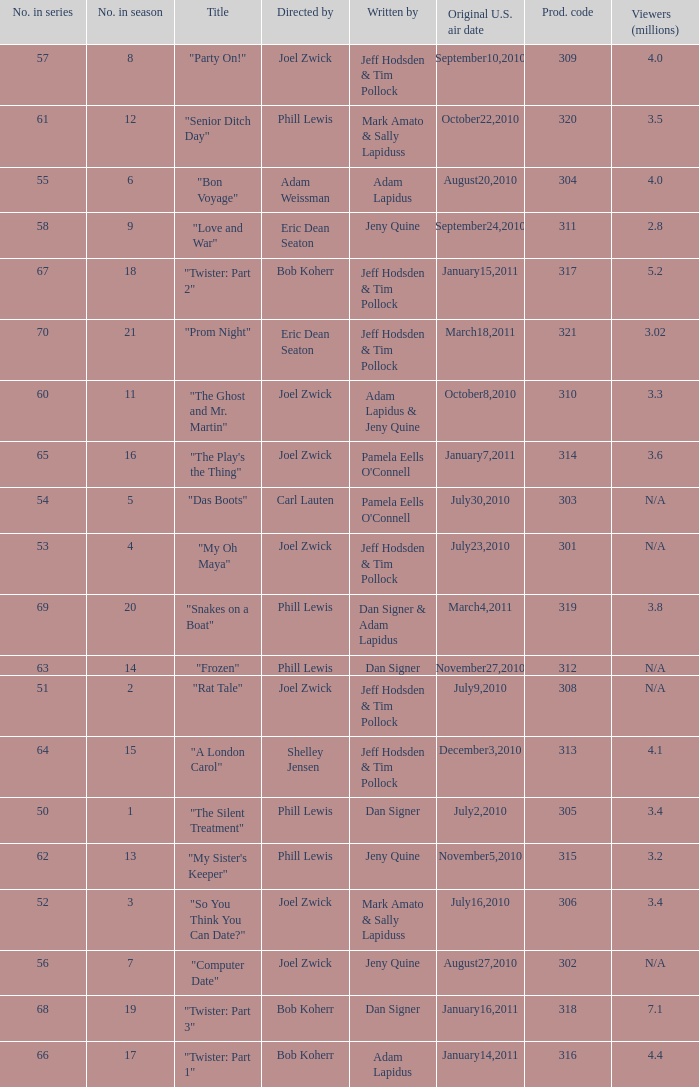Which US air date had 4.4 million viewers? January14,2011. 